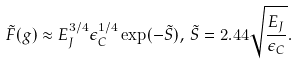Convert formula to latex. <formula><loc_0><loc_0><loc_500><loc_500>\tilde { F } ( g ) \approx E _ { J } ^ { 3 / 4 } \epsilon _ { C } ^ { 1 / 4 } \exp ( - \tilde { S } ) , \, \tilde { S } = 2 . 4 4 \sqrt { \frac { E _ { J } } { \epsilon _ { C } } } .</formula> 